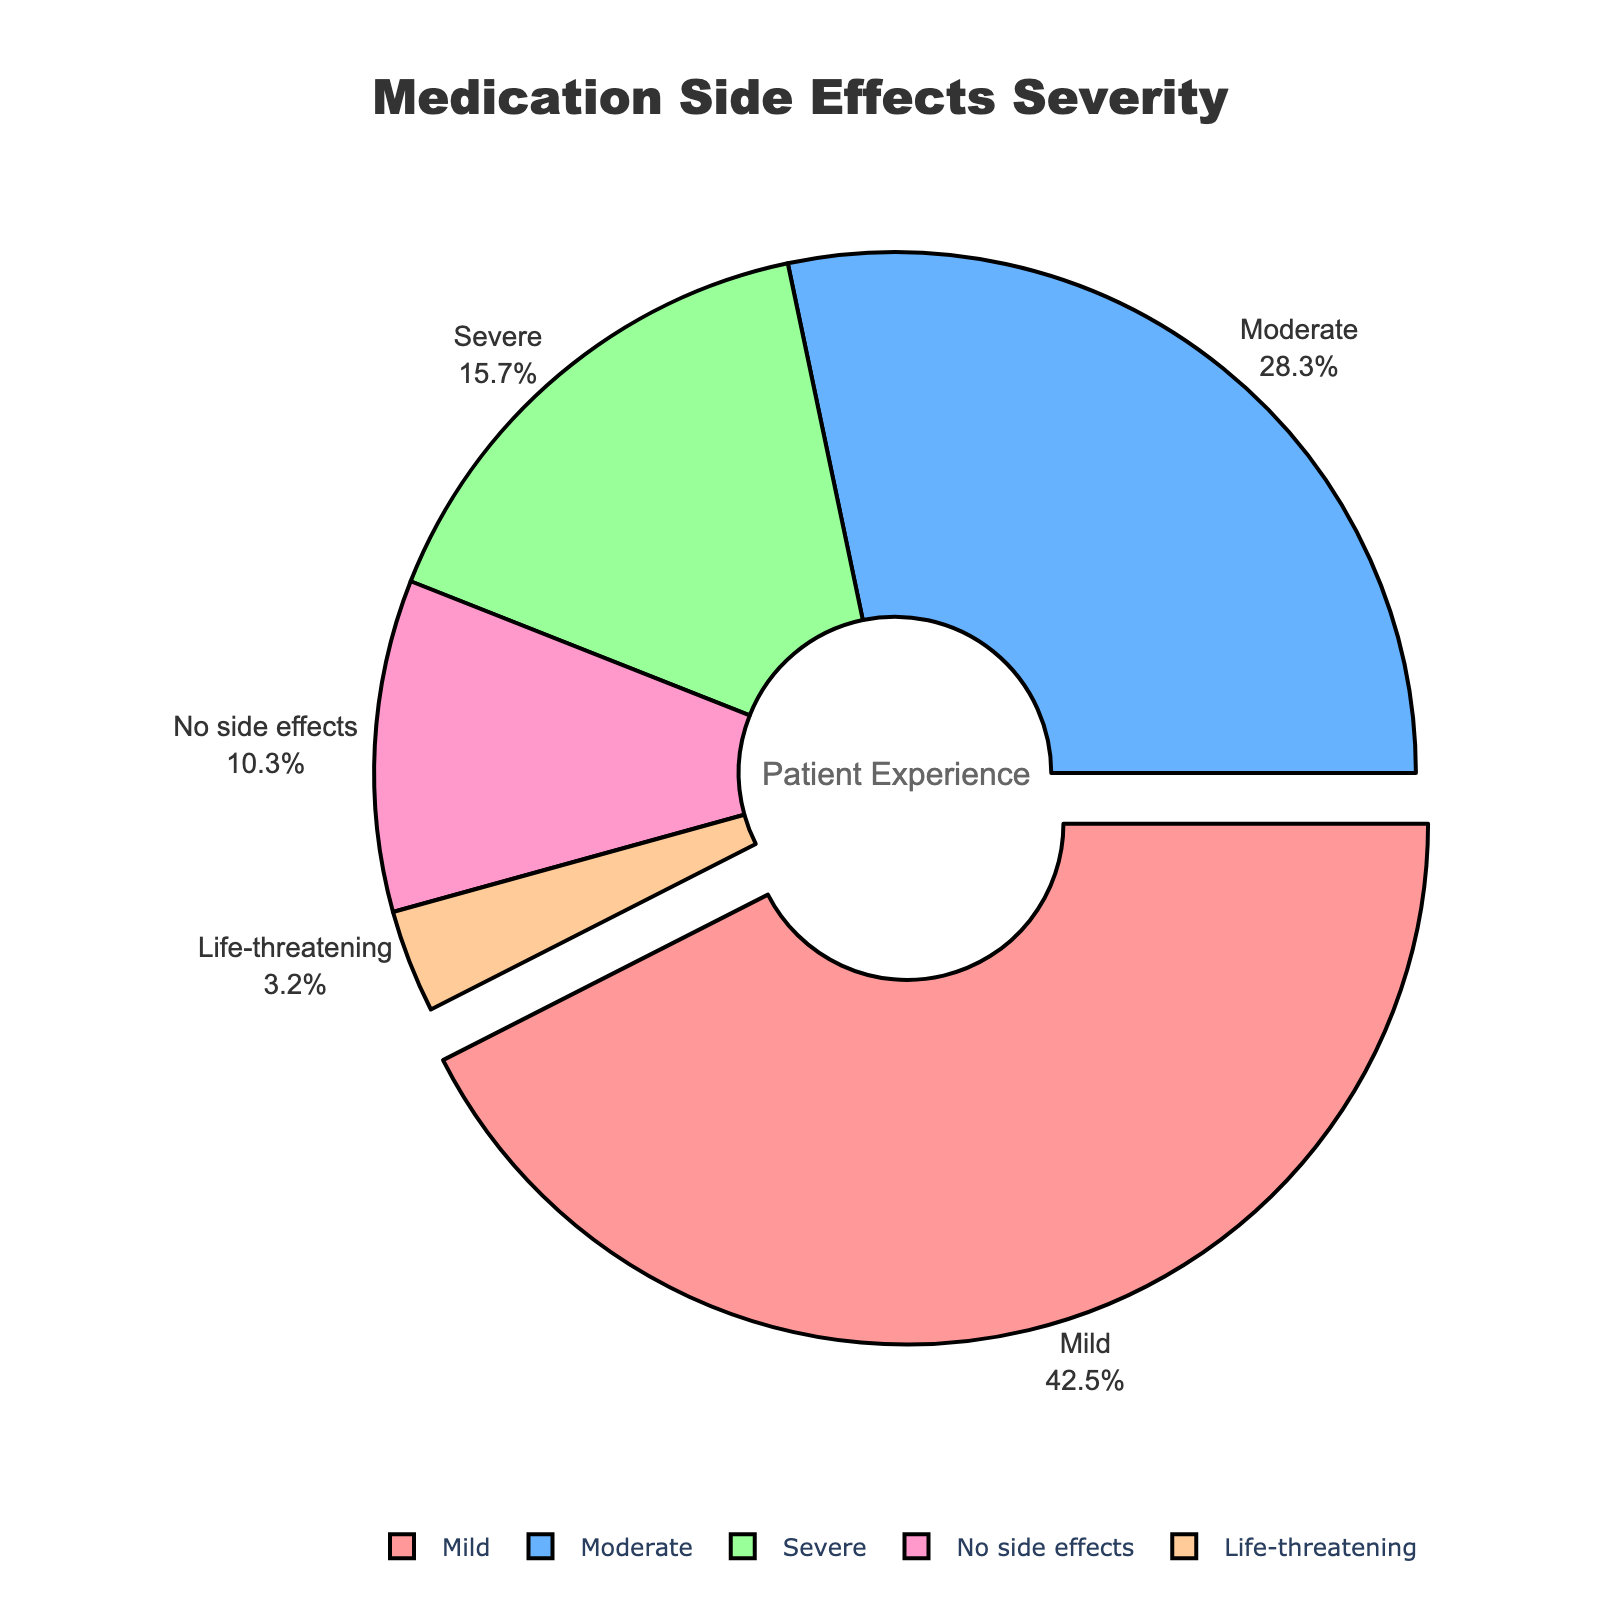What's the largest percentage of patients experiencing medication side effects and what severity is associated with it? The largest percentage can be identified by looking for the part of the pie chart that visually pulls out (called "explode" or "pull" in pie chart terminology). It represents patients experiencing mild side effects.
Answer: Mild, 42.5% What is the total percentage of patients who experienced moderate or worse side effects? Combine the percentages for moderate, severe, and life-threatening side effects: 28.3 (moderate) + 15.7 (severe) + 3.2 (life-threatening) = 47.2%.
Answer: 47.2% Which category of side effects has the smallest percentage of patients? Look for the smallest slice in the pie chart, which corresponds to patients experiencing life-threatening side effects.
Answer: Life-threatening, 3.2% What is the difference between the percentage of patients with no side effects and those with severe side effects? Subtract the percentage of patients experiencing severe side effects from those with no side effects: 10.3 (no side effects) - 15.7 (severe) = -5.4%.
Answer: -5.4% How much larger is the percentage of patients with mild side effects compared to those with life-threatening side effects? Subtract the percentage of patients with life-threatening side effects from those with mild side effects: 42.5 (mild) - 3.2 (life-threatening) = 39.3%.
Answer: 39.3% What percentage of patients did not experience any side effects? Identify the slice of the pie chart labeled "No side effects" and note its associated percentage.
Answer: 10.3% What is the combined percentage of patients with mild and moderate side effects? Add the percentages for mild and moderate side effects: 42.5 (mild) + 28.3 (moderate) = 70.8%.
Answer: 70.8% Which segment is represented by the color with the least visual prominence in the pie chart? Life-threatening side effects, which are shown by a smaller segment and a less visually prominent color compared to other segments.
Answer: Life-threatening, 3.2% What percentage of patients experienced side effects that are considered severe or worse? Add the percentages for severe and life-threatening side effects: 15.7 (severe) + 3.2 (life-threatening) = 18.9%.
Answer: 18.9% How does the percentage of patients with moderate side effects compare with those having mild side effects? Compare the percentages of patients with moderate and mild side effects: 28.3% (moderate) is less than 42.5% (mild).
Answer: Less, 28.3% vs. 42.5% 